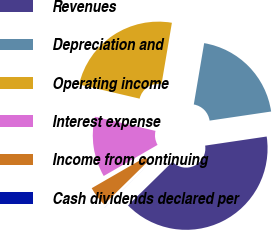<chart> <loc_0><loc_0><loc_500><loc_500><pie_chart><fcel>Revenues<fcel>Depreciation and<fcel>Operating income<fcel>Interest expense<fcel>Income from continuing<fcel>Cash dividends declared per<nl><fcel>39.99%<fcel>20.0%<fcel>24.0%<fcel>12.0%<fcel>4.0%<fcel>0.01%<nl></chart> 